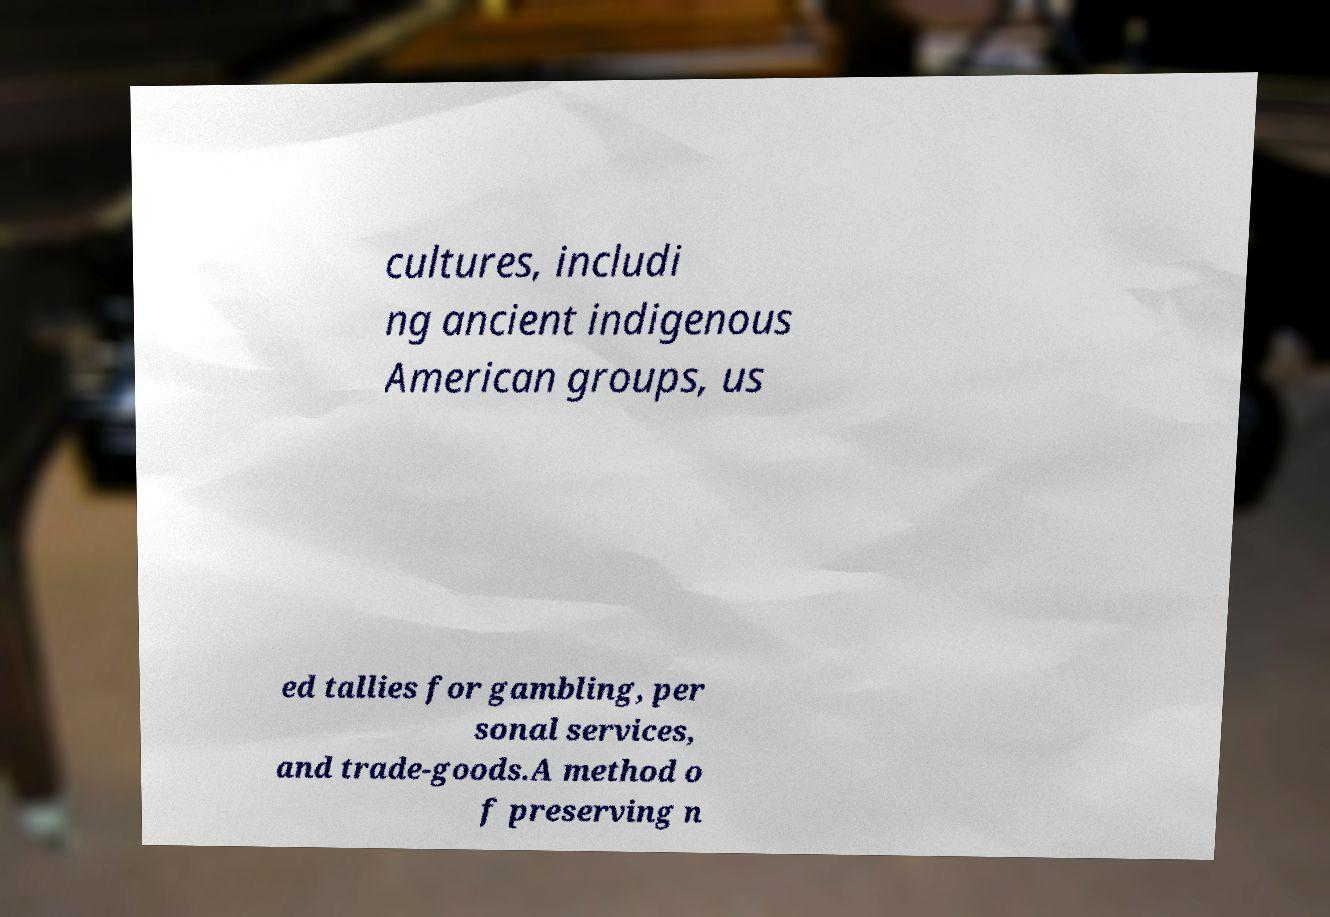Please read and relay the text visible in this image. What does it say? cultures, includi ng ancient indigenous American groups, us ed tallies for gambling, per sonal services, and trade-goods.A method o f preserving n 